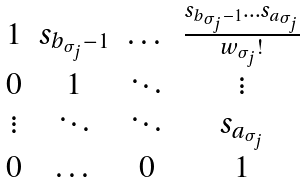Convert formula to latex. <formula><loc_0><loc_0><loc_500><loc_500>\begin{matrix} 1 & s _ { b _ { \sigma _ { j } } - 1 } & \dots & \frac { s _ { b _ { \sigma _ { j } } - 1 } \dots s _ { a _ { \sigma _ { j } } } } { w _ { \sigma _ { j } } ! } \\ 0 & 1 & \ddots & \vdots \\ \vdots & \ddots & \ddots & s _ { a _ { \sigma _ { j } } } \\ 0 & \dots & 0 & 1 \end{matrix}</formula> 